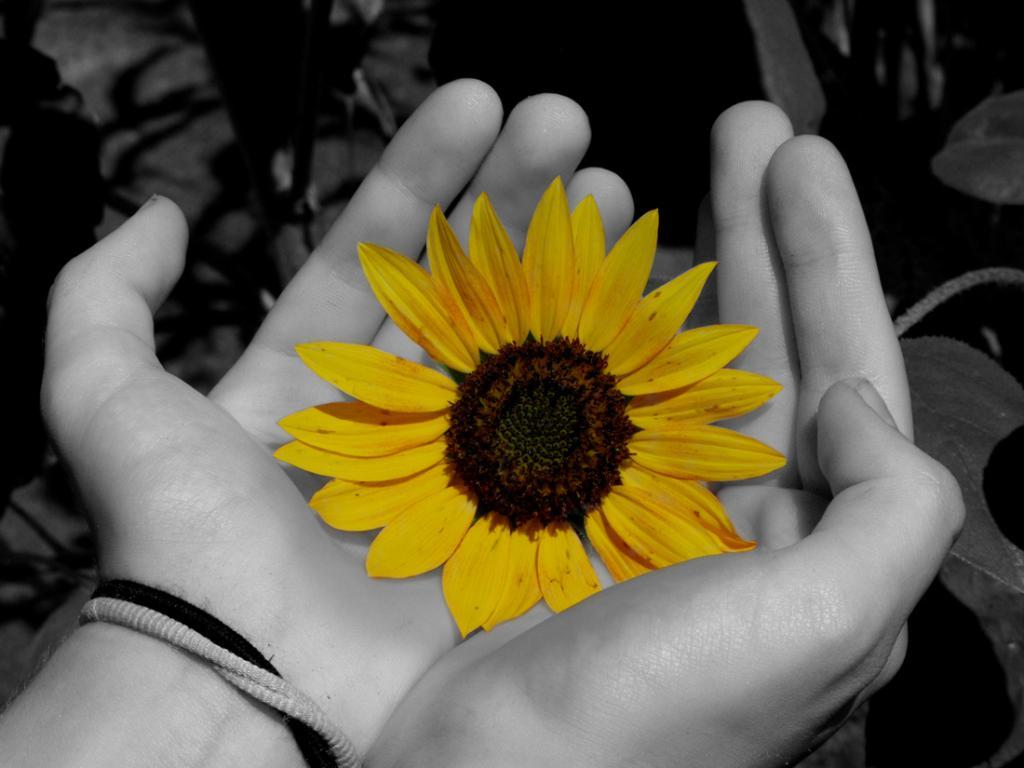What is being held by the human hands in the image? Human hands are holding a flower in the image. What color is the flower being held? The flower is yellow. What else can be seen in the image besides the flower? There are plants visible in the image. What branch of science is being studied in the image? There is no indication of any scientific study being conducted in the image. 